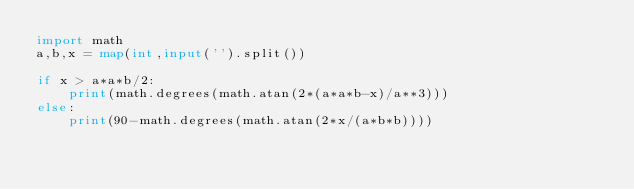Convert code to text. <code><loc_0><loc_0><loc_500><loc_500><_Python_>import math
a,b,x = map(int,input('').split())

if x > a*a*b/2:
    print(math.degrees(math.atan(2*(a*a*b-x)/a**3)))
else:
    print(90-math.degrees(math.atan(2*x/(a*b*b))))</code> 